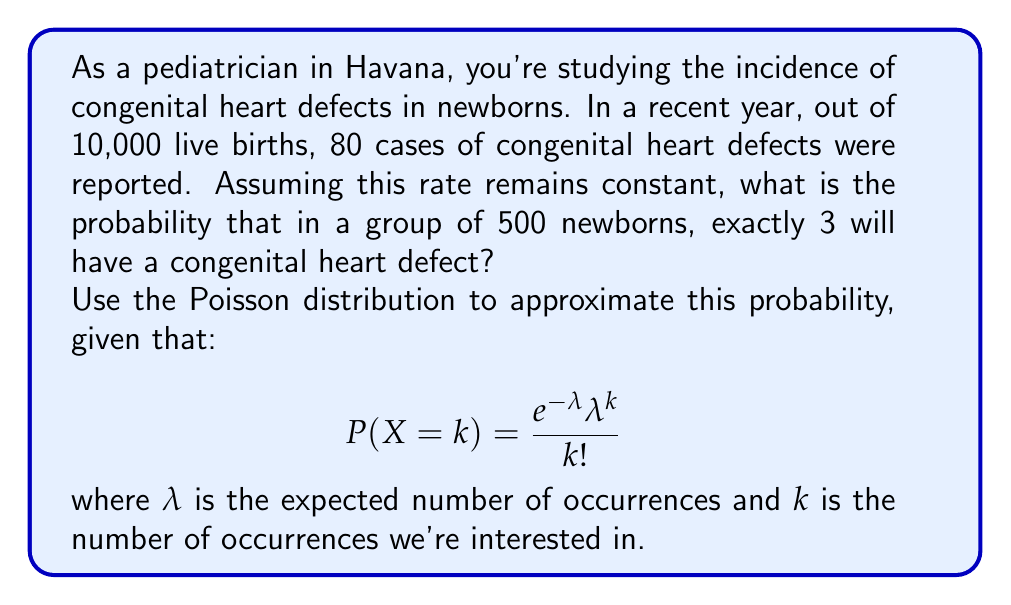Teach me how to tackle this problem. Let's approach this step-by-step:

1) First, we need to calculate the rate of congenital heart defects:
   $\frac{80}{10,000} = 0.008$ or 0.8%

2) For our group of 500 newborns, the expected number of cases ($\lambda$) is:
   $\lambda = 500 \times 0.008 = 4$

3) We want to find the probability of exactly 3 cases ($k = 3$) in this group.

4) Now we can use the Poisson distribution formula:

   $$P(X = 3) = \frac{e^{-4}4^3}{3!}$$

5) Let's calculate this step-by-step:
   
   $e^{-4} \approx 0.0183$
   $4^3 = 64$
   $3! = 6$

   $$P(X = 3) = \frac{0.0183 \times 64}{6} \approx 0.1954$$

6) Convert to a percentage: 0.1954 × 100% ≈ 19.54%

Therefore, the probability of exactly 3 newborns having a congenital heart defect in a group of 500 is approximately 19.54%.
Answer: 19.54% 